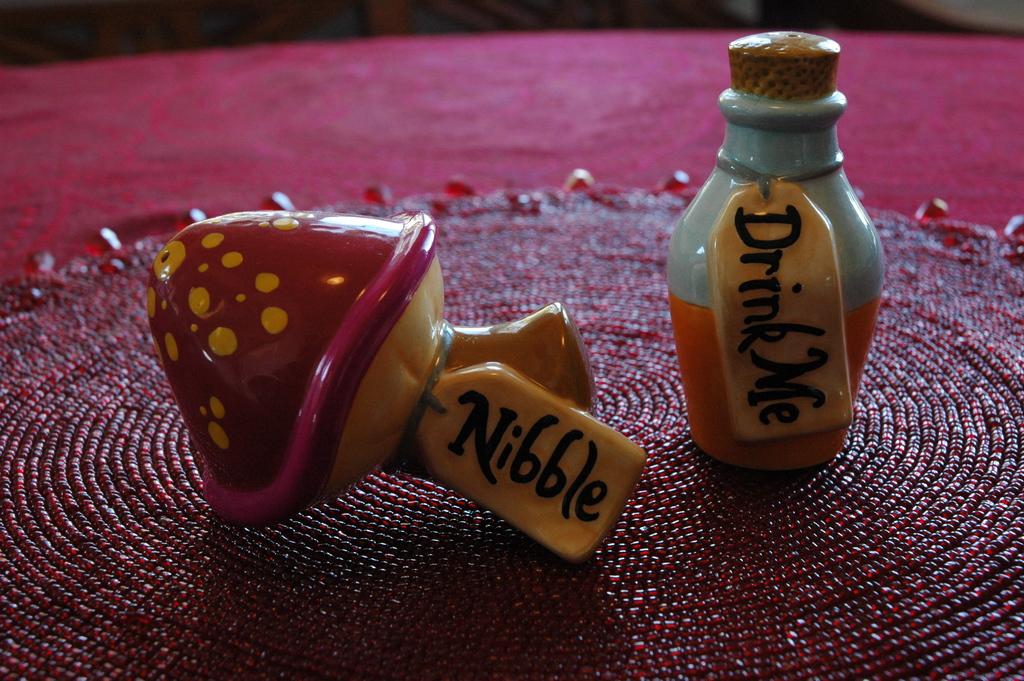What word is on the mushroom's tag?
Give a very brief answer. Nibble. 